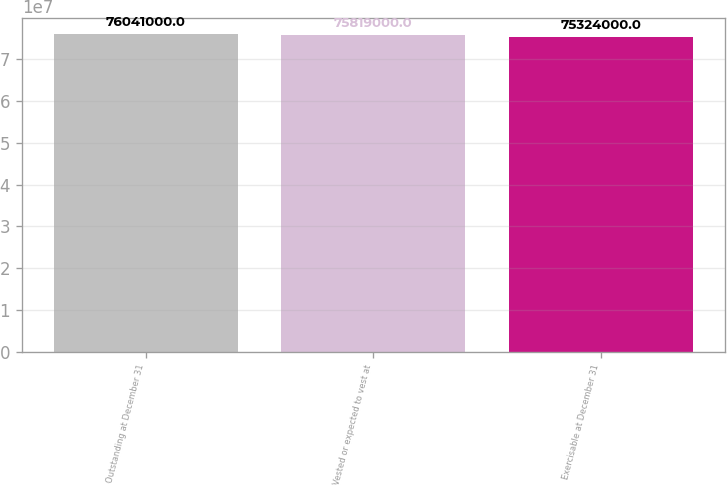Convert chart to OTSL. <chart><loc_0><loc_0><loc_500><loc_500><bar_chart><fcel>Outstanding at December 31<fcel>Vested or expected to vest at<fcel>Exercisable at December 31<nl><fcel>7.6041e+07<fcel>7.5819e+07<fcel>7.5324e+07<nl></chart> 